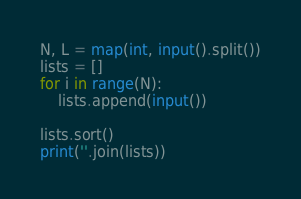<code> <loc_0><loc_0><loc_500><loc_500><_Python_>N, L = map(int, input().split())
lists = []
for i in range(N):
    lists.append(input())

lists.sort()
print(''.join(lists))</code> 